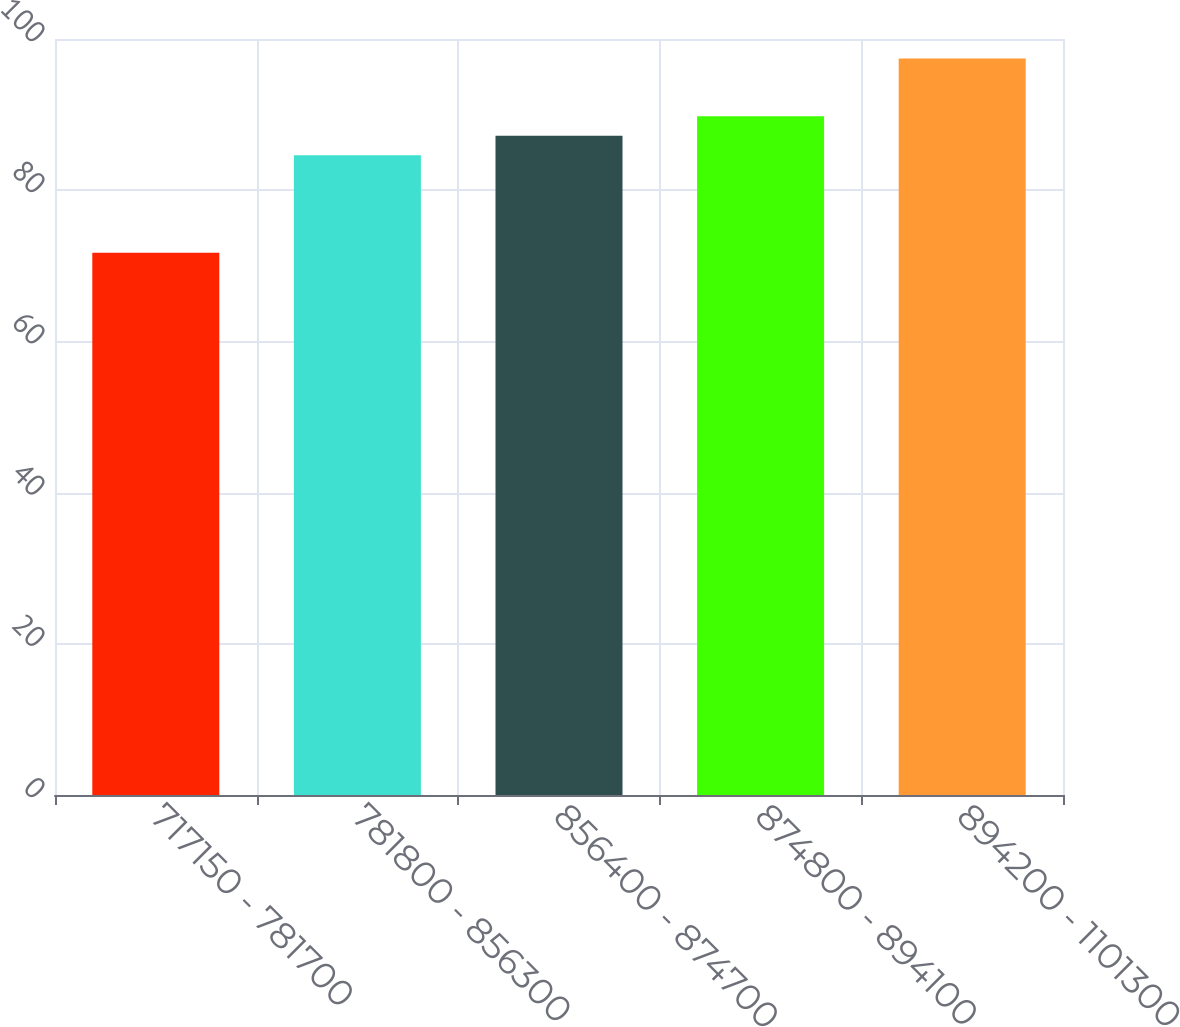Convert chart to OTSL. <chart><loc_0><loc_0><loc_500><loc_500><bar_chart><fcel>717150 - 781700<fcel>781800 - 856300<fcel>856400 - 874700<fcel>874800 - 894100<fcel>894200 - 1101300<nl><fcel>71.72<fcel>84.63<fcel>87.2<fcel>89.77<fcel>97.41<nl></chart> 